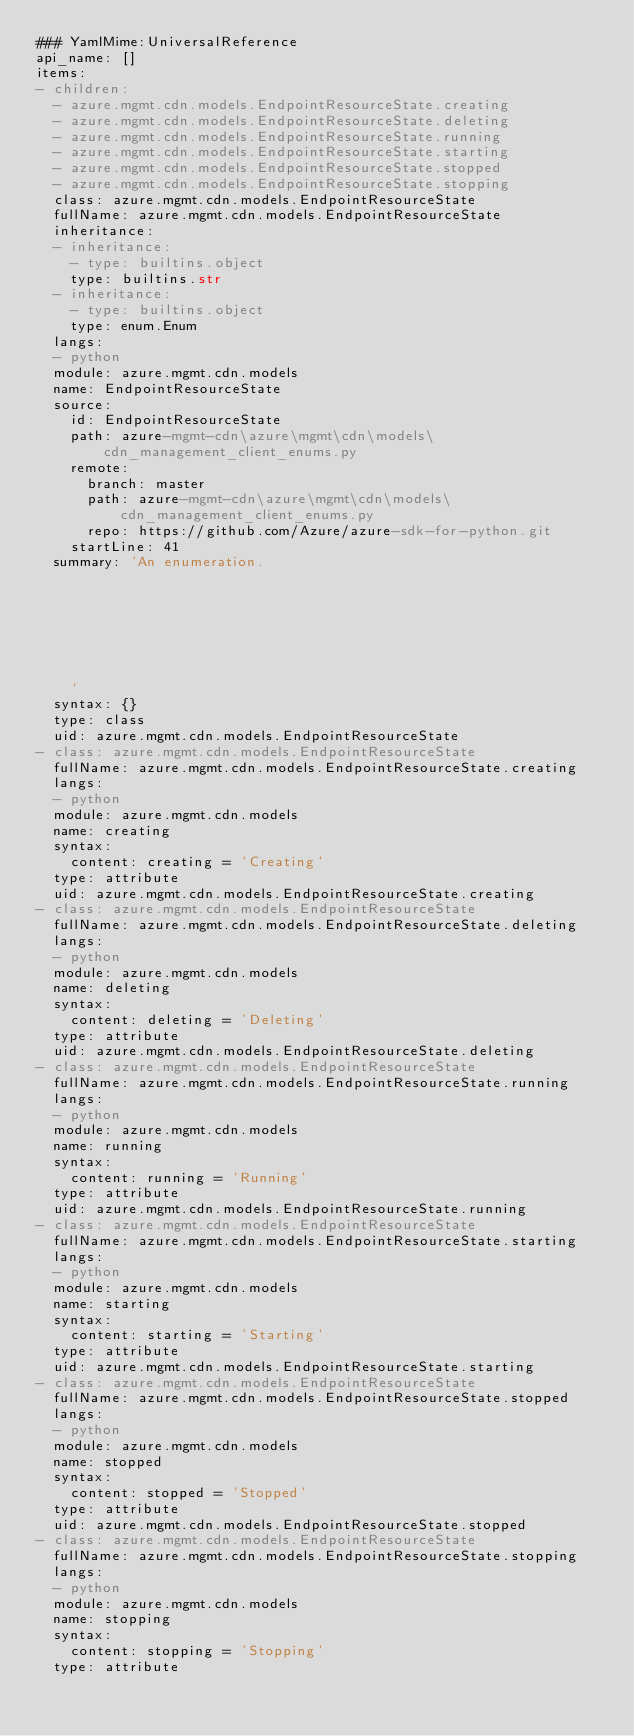<code> <loc_0><loc_0><loc_500><loc_500><_YAML_>### YamlMime:UniversalReference
api_name: []
items:
- children:
  - azure.mgmt.cdn.models.EndpointResourceState.creating
  - azure.mgmt.cdn.models.EndpointResourceState.deleting
  - azure.mgmt.cdn.models.EndpointResourceState.running
  - azure.mgmt.cdn.models.EndpointResourceState.starting
  - azure.mgmt.cdn.models.EndpointResourceState.stopped
  - azure.mgmt.cdn.models.EndpointResourceState.stopping
  class: azure.mgmt.cdn.models.EndpointResourceState
  fullName: azure.mgmt.cdn.models.EndpointResourceState
  inheritance:
  - inheritance:
    - type: builtins.object
    type: builtins.str
  - inheritance:
    - type: builtins.object
    type: enum.Enum
  langs:
  - python
  module: azure.mgmt.cdn.models
  name: EndpointResourceState
  source:
    id: EndpointResourceState
    path: azure-mgmt-cdn\azure\mgmt\cdn\models\cdn_management_client_enums.py
    remote:
      branch: master
      path: azure-mgmt-cdn\azure\mgmt\cdn\models\cdn_management_client_enums.py
      repo: https://github.com/Azure/azure-sdk-for-python.git
    startLine: 41
  summary: 'An enumeration.







    '
  syntax: {}
  type: class
  uid: azure.mgmt.cdn.models.EndpointResourceState
- class: azure.mgmt.cdn.models.EndpointResourceState
  fullName: azure.mgmt.cdn.models.EndpointResourceState.creating
  langs:
  - python
  module: azure.mgmt.cdn.models
  name: creating
  syntax:
    content: creating = 'Creating'
  type: attribute
  uid: azure.mgmt.cdn.models.EndpointResourceState.creating
- class: azure.mgmt.cdn.models.EndpointResourceState
  fullName: azure.mgmt.cdn.models.EndpointResourceState.deleting
  langs:
  - python
  module: azure.mgmt.cdn.models
  name: deleting
  syntax:
    content: deleting = 'Deleting'
  type: attribute
  uid: azure.mgmt.cdn.models.EndpointResourceState.deleting
- class: azure.mgmt.cdn.models.EndpointResourceState
  fullName: azure.mgmt.cdn.models.EndpointResourceState.running
  langs:
  - python
  module: azure.mgmt.cdn.models
  name: running
  syntax:
    content: running = 'Running'
  type: attribute
  uid: azure.mgmt.cdn.models.EndpointResourceState.running
- class: azure.mgmt.cdn.models.EndpointResourceState
  fullName: azure.mgmt.cdn.models.EndpointResourceState.starting
  langs:
  - python
  module: azure.mgmt.cdn.models
  name: starting
  syntax:
    content: starting = 'Starting'
  type: attribute
  uid: azure.mgmt.cdn.models.EndpointResourceState.starting
- class: azure.mgmt.cdn.models.EndpointResourceState
  fullName: azure.mgmt.cdn.models.EndpointResourceState.stopped
  langs:
  - python
  module: azure.mgmt.cdn.models
  name: stopped
  syntax:
    content: stopped = 'Stopped'
  type: attribute
  uid: azure.mgmt.cdn.models.EndpointResourceState.stopped
- class: azure.mgmt.cdn.models.EndpointResourceState
  fullName: azure.mgmt.cdn.models.EndpointResourceState.stopping
  langs:
  - python
  module: azure.mgmt.cdn.models
  name: stopping
  syntax:
    content: stopping = 'Stopping'
  type: attribute</code> 